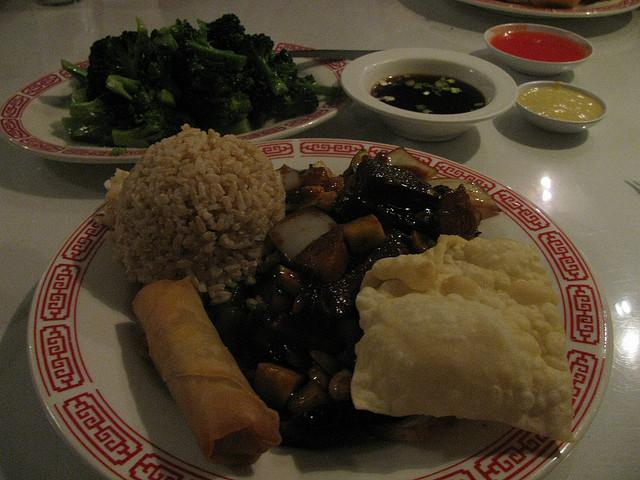What is used to sook the food? Please explain your reasoning. stove. A stove is used to keep the food hot and warm prior to preparation. 